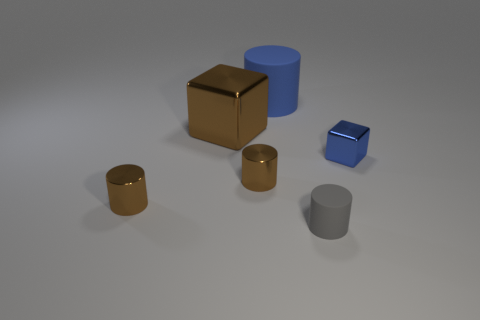Does the cube that is to the left of the tiny gray rubber thing have the same material as the tiny blue thing?
Offer a terse response. Yes. What material is the cylinder behind the shiny block that is left of the blue cylinder?
Offer a very short reply. Rubber. What number of other small blue things have the same shape as the small blue metallic object?
Your answer should be compact. 0. There is a cylinder right of the big blue thing behind the cube that is on the right side of the small rubber object; what size is it?
Ensure brevity in your answer.  Small. How many blue objects are either small objects or rubber cylinders?
Make the answer very short. 2. Is the shape of the rubber object in front of the blue cube the same as  the tiny blue thing?
Provide a succinct answer. No. Is the number of objects that are to the left of the big metal block greater than the number of purple cylinders?
Make the answer very short. Yes. How many brown cubes are the same size as the gray matte object?
Give a very brief answer. 0. What is the size of the cube that is the same color as the big cylinder?
Offer a very short reply. Small. How many objects are tiny cyan spheres or blocks on the left side of the big blue rubber thing?
Give a very brief answer. 1. 